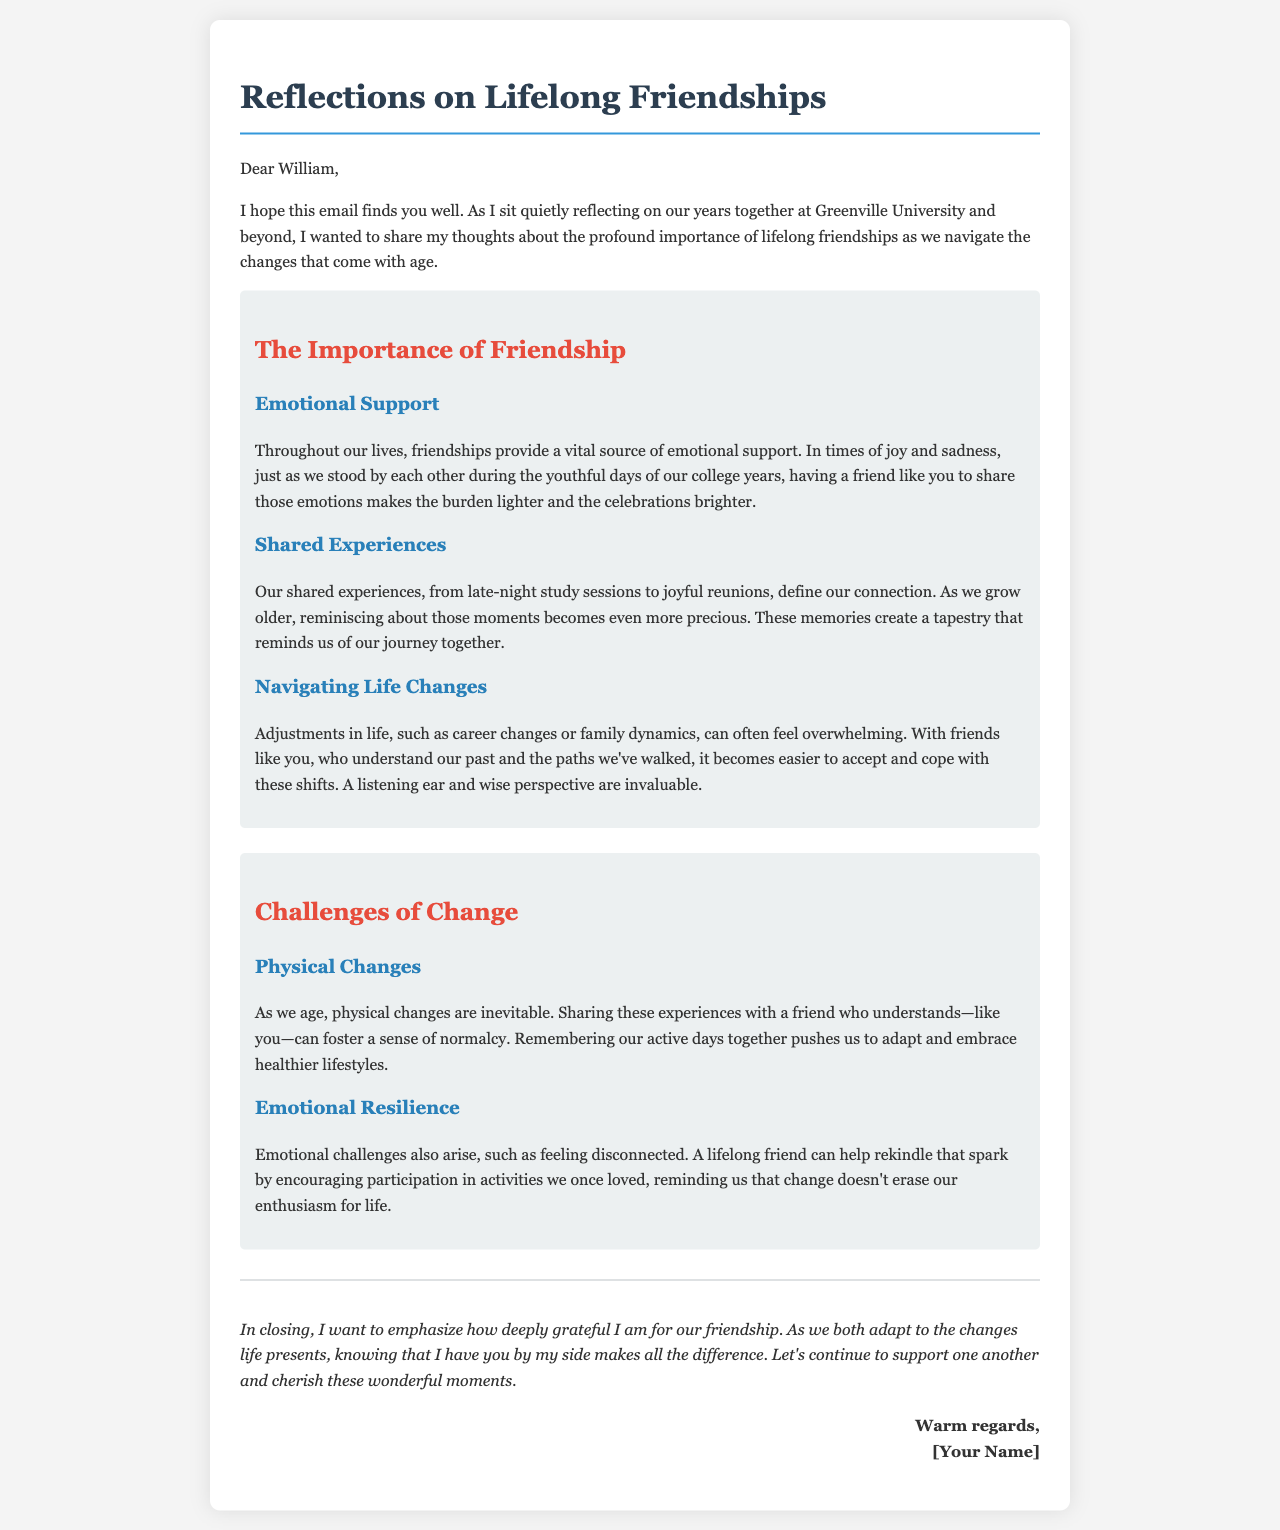What is the title of the email? The title of the email as stated in the document is "Reflections on Lifelong Friendships."
Answer: Reflections on Lifelong Friendships Who is the email addressed to? The email is specifically addressed to William, as mentioned in the greeting.
Answer: William What are the two main topics discussed in the document? The document discusses "The Importance of Friendship" and "Challenges of Change."
Answer: The Importance of Friendship and Challenges of Change What provides emotional support according to the document? The document mentions that friendships provide a vital source of emotional support throughout our lives.
Answer: Friendships What aspect of friendship helps to navigate life changes? The document states that having friends who understand our past helps to accept and cope with life changes.
Answer: Understanding our past What is a key benefit of sharing experiences according to the document? Sharing experiences creates a tapestry that reminds us of our journey together, making those moments more precious as we grow older.
Answer: Reminds us of our journey How does the document suggest coping with physical changes as we age? The document suggests that sharing experiences with a friend who understands can foster a sense of normalcy.
Answer: Foster a sense of normalcy What emotional challenges arise as we age? The document mentions feeling disconnected as an emotional challenge that can arise with age.
Answer: Feeling disconnected What is the closing sentiment expressed in the email? The closing sentiment emphasizes gratitude for friendship and the importance of continuing to support one another.
Answer: Grateful for our friendship 